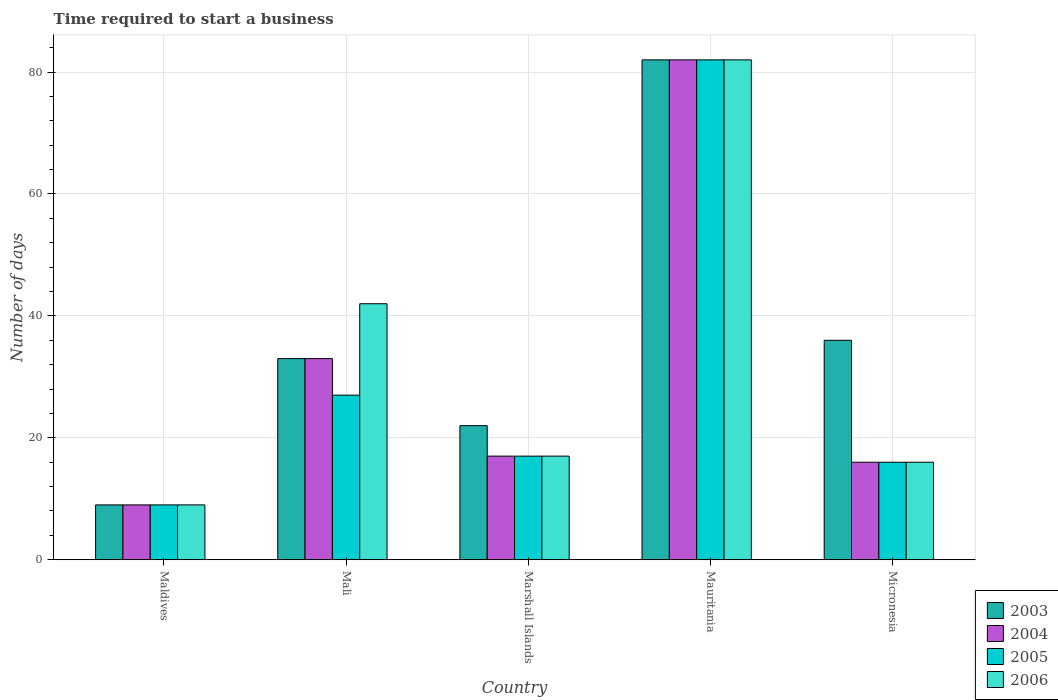How many groups of bars are there?
Your answer should be compact. 5. Are the number of bars per tick equal to the number of legend labels?
Your answer should be compact. Yes. Are the number of bars on each tick of the X-axis equal?
Ensure brevity in your answer.  Yes. How many bars are there on the 1st tick from the right?
Ensure brevity in your answer.  4. What is the label of the 2nd group of bars from the left?
Your response must be concise. Mali. What is the number of days required to start a business in 2004 in Mali?
Your answer should be very brief. 33. Across all countries, what is the maximum number of days required to start a business in 2004?
Provide a succinct answer. 82. In which country was the number of days required to start a business in 2006 maximum?
Your answer should be very brief. Mauritania. In which country was the number of days required to start a business in 2005 minimum?
Your answer should be compact. Maldives. What is the total number of days required to start a business in 2005 in the graph?
Provide a succinct answer. 151. What is the difference between the number of days required to start a business in 2005 in Mauritania and the number of days required to start a business in 2003 in Marshall Islands?
Your answer should be very brief. 60. What is the average number of days required to start a business in 2006 per country?
Provide a succinct answer. 33.2. What is the ratio of the number of days required to start a business in 2003 in Maldives to that in Micronesia?
Provide a succinct answer. 0.25. Is the difference between the number of days required to start a business in 2004 in Marshall Islands and Micronesia greater than the difference between the number of days required to start a business in 2005 in Marshall Islands and Micronesia?
Provide a short and direct response. No. What is the difference between the highest and the second highest number of days required to start a business in 2003?
Make the answer very short. -49. What is the difference between the highest and the lowest number of days required to start a business in 2004?
Provide a short and direct response. 73. Is the sum of the number of days required to start a business in 2003 in Mali and Marshall Islands greater than the maximum number of days required to start a business in 2004 across all countries?
Give a very brief answer. No. Is it the case that in every country, the sum of the number of days required to start a business in 2005 and number of days required to start a business in 2006 is greater than the sum of number of days required to start a business in 2004 and number of days required to start a business in 2003?
Provide a short and direct response. No. What does the 1st bar from the right in Mali represents?
Your answer should be compact. 2006. Is it the case that in every country, the sum of the number of days required to start a business in 2003 and number of days required to start a business in 2005 is greater than the number of days required to start a business in 2006?
Offer a terse response. Yes. How many bars are there?
Make the answer very short. 20. Are all the bars in the graph horizontal?
Your response must be concise. No. How many countries are there in the graph?
Make the answer very short. 5. Does the graph contain grids?
Your answer should be very brief. Yes. How are the legend labels stacked?
Offer a very short reply. Vertical. What is the title of the graph?
Offer a terse response. Time required to start a business. Does "1960" appear as one of the legend labels in the graph?
Provide a short and direct response. No. What is the label or title of the Y-axis?
Ensure brevity in your answer.  Number of days. What is the Number of days in 2003 in Maldives?
Provide a succinct answer. 9. What is the Number of days in 2005 in Maldives?
Your response must be concise. 9. What is the Number of days in 2003 in Mali?
Keep it short and to the point. 33. What is the Number of days in 2005 in Mali?
Ensure brevity in your answer.  27. What is the Number of days of 2006 in Mali?
Offer a very short reply. 42. What is the Number of days in 2004 in Marshall Islands?
Your answer should be compact. 17. What is the Number of days in 2005 in Mauritania?
Provide a short and direct response. 82. What is the Number of days in 2003 in Micronesia?
Give a very brief answer. 36. What is the Number of days of 2004 in Micronesia?
Provide a succinct answer. 16. Across all countries, what is the maximum Number of days of 2003?
Your answer should be compact. 82. Across all countries, what is the maximum Number of days of 2005?
Provide a succinct answer. 82. Across all countries, what is the minimum Number of days in 2004?
Provide a succinct answer. 9. Across all countries, what is the minimum Number of days of 2005?
Offer a terse response. 9. Across all countries, what is the minimum Number of days of 2006?
Make the answer very short. 9. What is the total Number of days in 2003 in the graph?
Your answer should be very brief. 182. What is the total Number of days in 2004 in the graph?
Your answer should be compact. 157. What is the total Number of days of 2005 in the graph?
Offer a terse response. 151. What is the total Number of days in 2006 in the graph?
Give a very brief answer. 166. What is the difference between the Number of days in 2005 in Maldives and that in Mali?
Provide a succinct answer. -18. What is the difference between the Number of days of 2006 in Maldives and that in Mali?
Keep it short and to the point. -33. What is the difference between the Number of days in 2004 in Maldives and that in Marshall Islands?
Give a very brief answer. -8. What is the difference between the Number of days of 2005 in Maldives and that in Marshall Islands?
Keep it short and to the point. -8. What is the difference between the Number of days of 2003 in Maldives and that in Mauritania?
Offer a terse response. -73. What is the difference between the Number of days of 2004 in Maldives and that in Mauritania?
Offer a very short reply. -73. What is the difference between the Number of days in 2005 in Maldives and that in Mauritania?
Ensure brevity in your answer.  -73. What is the difference between the Number of days in 2006 in Maldives and that in Mauritania?
Make the answer very short. -73. What is the difference between the Number of days of 2003 in Maldives and that in Micronesia?
Offer a very short reply. -27. What is the difference between the Number of days in 2004 in Maldives and that in Micronesia?
Your response must be concise. -7. What is the difference between the Number of days in 2005 in Maldives and that in Micronesia?
Your answer should be compact. -7. What is the difference between the Number of days in 2006 in Maldives and that in Micronesia?
Keep it short and to the point. -7. What is the difference between the Number of days in 2003 in Mali and that in Mauritania?
Offer a very short reply. -49. What is the difference between the Number of days in 2004 in Mali and that in Mauritania?
Keep it short and to the point. -49. What is the difference between the Number of days in 2005 in Mali and that in Mauritania?
Make the answer very short. -55. What is the difference between the Number of days in 2006 in Mali and that in Mauritania?
Offer a very short reply. -40. What is the difference between the Number of days in 2003 in Mali and that in Micronesia?
Offer a very short reply. -3. What is the difference between the Number of days in 2004 in Mali and that in Micronesia?
Offer a very short reply. 17. What is the difference between the Number of days of 2003 in Marshall Islands and that in Mauritania?
Give a very brief answer. -60. What is the difference between the Number of days of 2004 in Marshall Islands and that in Mauritania?
Ensure brevity in your answer.  -65. What is the difference between the Number of days of 2005 in Marshall Islands and that in Mauritania?
Give a very brief answer. -65. What is the difference between the Number of days in 2006 in Marshall Islands and that in Mauritania?
Give a very brief answer. -65. What is the difference between the Number of days in 2005 in Marshall Islands and that in Micronesia?
Give a very brief answer. 1. What is the difference between the Number of days of 2006 in Marshall Islands and that in Micronesia?
Make the answer very short. 1. What is the difference between the Number of days of 2003 in Mauritania and that in Micronesia?
Ensure brevity in your answer.  46. What is the difference between the Number of days of 2004 in Mauritania and that in Micronesia?
Provide a succinct answer. 66. What is the difference between the Number of days of 2006 in Mauritania and that in Micronesia?
Your response must be concise. 66. What is the difference between the Number of days in 2003 in Maldives and the Number of days in 2005 in Mali?
Your answer should be compact. -18. What is the difference between the Number of days in 2003 in Maldives and the Number of days in 2006 in Mali?
Provide a short and direct response. -33. What is the difference between the Number of days of 2004 in Maldives and the Number of days of 2006 in Mali?
Make the answer very short. -33. What is the difference between the Number of days in 2005 in Maldives and the Number of days in 2006 in Mali?
Provide a succinct answer. -33. What is the difference between the Number of days of 2003 in Maldives and the Number of days of 2004 in Marshall Islands?
Offer a very short reply. -8. What is the difference between the Number of days in 2003 in Maldives and the Number of days in 2005 in Marshall Islands?
Your answer should be compact. -8. What is the difference between the Number of days of 2005 in Maldives and the Number of days of 2006 in Marshall Islands?
Make the answer very short. -8. What is the difference between the Number of days in 2003 in Maldives and the Number of days in 2004 in Mauritania?
Make the answer very short. -73. What is the difference between the Number of days of 2003 in Maldives and the Number of days of 2005 in Mauritania?
Make the answer very short. -73. What is the difference between the Number of days of 2003 in Maldives and the Number of days of 2006 in Mauritania?
Offer a very short reply. -73. What is the difference between the Number of days of 2004 in Maldives and the Number of days of 2005 in Mauritania?
Make the answer very short. -73. What is the difference between the Number of days of 2004 in Maldives and the Number of days of 2006 in Mauritania?
Keep it short and to the point. -73. What is the difference between the Number of days of 2005 in Maldives and the Number of days of 2006 in Mauritania?
Offer a very short reply. -73. What is the difference between the Number of days in 2003 in Maldives and the Number of days in 2006 in Micronesia?
Give a very brief answer. -7. What is the difference between the Number of days of 2005 in Maldives and the Number of days of 2006 in Micronesia?
Ensure brevity in your answer.  -7. What is the difference between the Number of days of 2003 in Mali and the Number of days of 2004 in Marshall Islands?
Your answer should be compact. 16. What is the difference between the Number of days in 2003 in Mali and the Number of days in 2004 in Mauritania?
Give a very brief answer. -49. What is the difference between the Number of days of 2003 in Mali and the Number of days of 2005 in Mauritania?
Provide a short and direct response. -49. What is the difference between the Number of days in 2003 in Mali and the Number of days in 2006 in Mauritania?
Give a very brief answer. -49. What is the difference between the Number of days of 2004 in Mali and the Number of days of 2005 in Mauritania?
Keep it short and to the point. -49. What is the difference between the Number of days of 2004 in Mali and the Number of days of 2006 in Mauritania?
Ensure brevity in your answer.  -49. What is the difference between the Number of days in 2005 in Mali and the Number of days in 2006 in Mauritania?
Your answer should be compact. -55. What is the difference between the Number of days of 2003 in Mali and the Number of days of 2006 in Micronesia?
Your answer should be very brief. 17. What is the difference between the Number of days of 2004 in Mali and the Number of days of 2006 in Micronesia?
Offer a terse response. 17. What is the difference between the Number of days in 2003 in Marshall Islands and the Number of days in 2004 in Mauritania?
Provide a succinct answer. -60. What is the difference between the Number of days in 2003 in Marshall Islands and the Number of days in 2005 in Mauritania?
Make the answer very short. -60. What is the difference between the Number of days of 2003 in Marshall Islands and the Number of days of 2006 in Mauritania?
Your answer should be compact. -60. What is the difference between the Number of days in 2004 in Marshall Islands and the Number of days in 2005 in Mauritania?
Give a very brief answer. -65. What is the difference between the Number of days in 2004 in Marshall Islands and the Number of days in 2006 in Mauritania?
Your answer should be compact. -65. What is the difference between the Number of days in 2005 in Marshall Islands and the Number of days in 2006 in Mauritania?
Make the answer very short. -65. What is the difference between the Number of days of 2003 in Marshall Islands and the Number of days of 2005 in Micronesia?
Ensure brevity in your answer.  6. What is the difference between the Number of days of 2004 in Marshall Islands and the Number of days of 2005 in Micronesia?
Ensure brevity in your answer.  1. What is the difference between the Number of days in 2004 in Marshall Islands and the Number of days in 2006 in Micronesia?
Ensure brevity in your answer.  1. What is the difference between the Number of days of 2004 in Mauritania and the Number of days of 2005 in Micronesia?
Keep it short and to the point. 66. What is the difference between the Number of days in 2004 in Mauritania and the Number of days in 2006 in Micronesia?
Your response must be concise. 66. What is the average Number of days of 2003 per country?
Ensure brevity in your answer.  36.4. What is the average Number of days of 2004 per country?
Provide a short and direct response. 31.4. What is the average Number of days in 2005 per country?
Provide a short and direct response. 30.2. What is the average Number of days of 2006 per country?
Give a very brief answer. 33.2. What is the difference between the Number of days in 2003 and Number of days in 2006 in Maldives?
Offer a very short reply. 0. What is the difference between the Number of days in 2004 and Number of days in 2005 in Maldives?
Provide a short and direct response. 0. What is the difference between the Number of days in 2005 and Number of days in 2006 in Maldives?
Keep it short and to the point. 0. What is the difference between the Number of days of 2004 and Number of days of 2005 in Mali?
Keep it short and to the point. 6. What is the difference between the Number of days of 2004 and Number of days of 2006 in Mali?
Offer a terse response. -9. What is the difference between the Number of days of 2005 and Number of days of 2006 in Mali?
Provide a short and direct response. -15. What is the difference between the Number of days in 2003 and Number of days in 2006 in Marshall Islands?
Make the answer very short. 5. What is the difference between the Number of days in 2005 and Number of days in 2006 in Marshall Islands?
Your response must be concise. 0. What is the difference between the Number of days in 2003 and Number of days in 2004 in Mauritania?
Provide a succinct answer. 0. What is the difference between the Number of days of 2004 and Number of days of 2006 in Mauritania?
Your response must be concise. 0. What is the difference between the Number of days in 2003 and Number of days in 2005 in Micronesia?
Keep it short and to the point. 20. What is the difference between the Number of days of 2003 and Number of days of 2006 in Micronesia?
Make the answer very short. 20. What is the difference between the Number of days in 2005 and Number of days in 2006 in Micronesia?
Offer a terse response. 0. What is the ratio of the Number of days of 2003 in Maldives to that in Mali?
Give a very brief answer. 0.27. What is the ratio of the Number of days in 2004 in Maldives to that in Mali?
Your answer should be compact. 0.27. What is the ratio of the Number of days of 2005 in Maldives to that in Mali?
Ensure brevity in your answer.  0.33. What is the ratio of the Number of days in 2006 in Maldives to that in Mali?
Keep it short and to the point. 0.21. What is the ratio of the Number of days of 2003 in Maldives to that in Marshall Islands?
Offer a terse response. 0.41. What is the ratio of the Number of days of 2004 in Maldives to that in Marshall Islands?
Provide a short and direct response. 0.53. What is the ratio of the Number of days of 2005 in Maldives to that in Marshall Islands?
Offer a very short reply. 0.53. What is the ratio of the Number of days of 2006 in Maldives to that in Marshall Islands?
Ensure brevity in your answer.  0.53. What is the ratio of the Number of days of 2003 in Maldives to that in Mauritania?
Give a very brief answer. 0.11. What is the ratio of the Number of days of 2004 in Maldives to that in Mauritania?
Offer a terse response. 0.11. What is the ratio of the Number of days in 2005 in Maldives to that in Mauritania?
Your answer should be very brief. 0.11. What is the ratio of the Number of days of 2006 in Maldives to that in Mauritania?
Offer a terse response. 0.11. What is the ratio of the Number of days in 2004 in Maldives to that in Micronesia?
Ensure brevity in your answer.  0.56. What is the ratio of the Number of days of 2005 in Maldives to that in Micronesia?
Offer a terse response. 0.56. What is the ratio of the Number of days of 2006 in Maldives to that in Micronesia?
Offer a very short reply. 0.56. What is the ratio of the Number of days in 2004 in Mali to that in Marshall Islands?
Your response must be concise. 1.94. What is the ratio of the Number of days of 2005 in Mali to that in Marshall Islands?
Make the answer very short. 1.59. What is the ratio of the Number of days of 2006 in Mali to that in Marshall Islands?
Provide a succinct answer. 2.47. What is the ratio of the Number of days of 2003 in Mali to that in Mauritania?
Make the answer very short. 0.4. What is the ratio of the Number of days of 2004 in Mali to that in Mauritania?
Your response must be concise. 0.4. What is the ratio of the Number of days of 2005 in Mali to that in Mauritania?
Provide a short and direct response. 0.33. What is the ratio of the Number of days of 2006 in Mali to that in Mauritania?
Provide a short and direct response. 0.51. What is the ratio of the Number of days of 2004 in Mali to that in Micronesia?
Your response must be concise. 2.06. What is the ratio of the Number of days of 2005 in Mali to that in Micronesia?
Your answer should be compact. 1.69. What is the ratio of the Number of days in 2006 in Mali to that in Micronesia?
Provide a succinct answer. 2.62. What is the ratio of the Number of days in 2003 in Marshall Islands to that in Mauritania?
Keep it short and to the point. 0.27. What is the ratio of the Number of days in 2004 in Marshall Islands to that in Mauritania?
Ensure brevity in your answer.  0.21. What is the ratio of the Number of days of 2005 in Marshall Islands to that in Mauritania?
Your response must be concise. 0.21. What is the ratio of the Number of days of 2006 in Marshall Islands to that in Mauritania?
Your response must be concise. 0.21. What is the ratio of the Number of days of 2003 in Marshall Islands to that in Micronesia?
Make the answer very short. 0.61. What is the ratio of the Number of days of 2005 in Marshall Islands to that in Micronesia?
Your response must be concise. 1.06. What is the ratio of the Number of days in 2006 in Marshall Islands to that in Micronesia?
Offer a terse response. 1.06. What is the ratio of the Number of days in 2003 in Mauritania to that in Micronesia?
Provide a short and direct response. 2.28. What is the ratio of the Number of days of 2004 in Mauritania to that in Micronesia?
Your answer should be very brief. 5.12. What is the ratio of the Number of days in 2005 in Mauritania to that in Micronesia?
Your response must be concise. 5.12. What is the ratio of the Number of days of 2006 in Mauritania to that in Micronesia?
Ensure brevity in your answer.  5.12. What is the difference between the highest and the second highest Number of days in 2003?
Give a very brief answer. 46. What is the difference between the highest and the second highest Number of days of 2005?
Offer a terse response. 55. What is the difference between the highest and the lowest Number of days of 2004?
Offer a very short reply. 73. What is the difference between the highest and the lowest Number of days in 2005?
Ensure brevity in your answer.  73. 